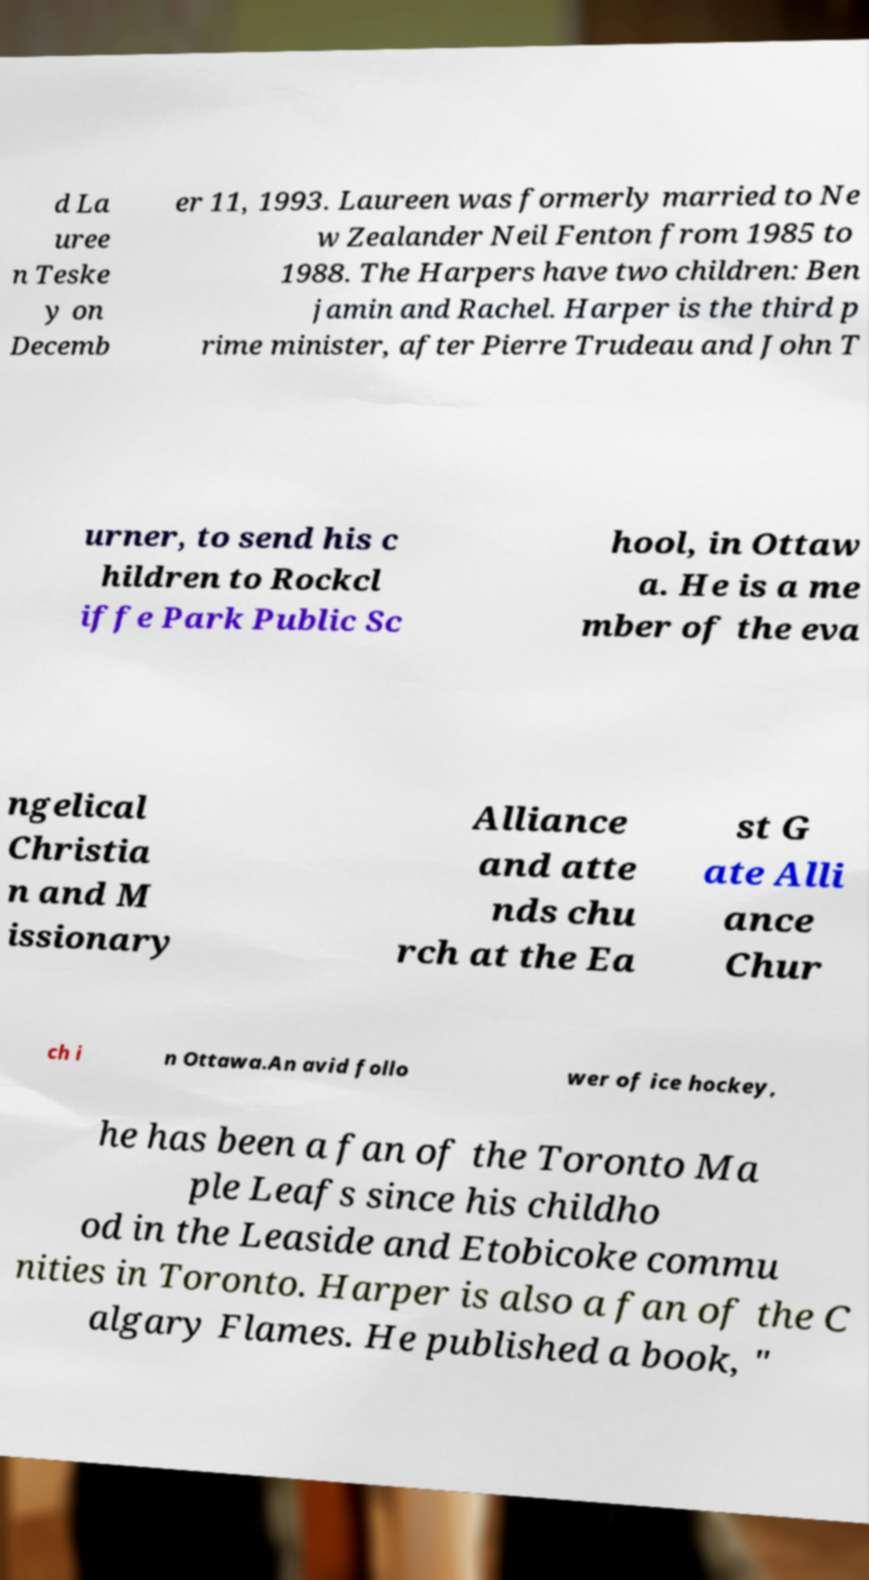What messages or text are displayed in this image? I need them in a readable, typed format. d La uree n Teske y on Decemb er 11, 1993. Laureen was formerly married to Ne w Zealander Neil Fenton from 1985 to 1988. The Harpers have two children: Ben jamin and Rachel. Harper is the third p rime minister, after Pierre Trudeau and John T urner, to send his c hildren to Rockcl iffe Park Public Sc hool, in Ottaw a. He is a me mber of the eva ngelical Christia n and M issionary Alliance and atte nds chu rch at the Ea st G ate Alli ance Chur ch i n Ottawa.An avid follo wer of ice hockey, he has been a fan of the Toronto Ma ple Leafs since his childho od in the Leaside and Etobicoke commu nities in Toronto. Harper is also a fan of the C algary Flames. He published a book, " 